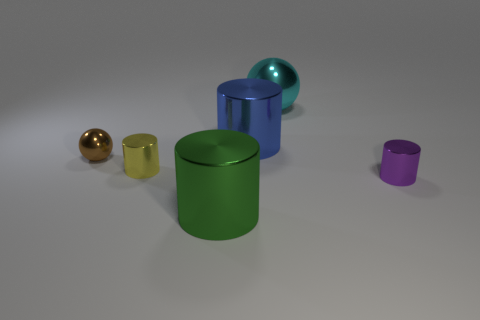Subtract 1 cylinders. How many cylinders are left? 3 Add 3 tiny yellow shiny cylinders. How many objects exist? 9 Subtract all cylinders. How many objects are left? 2 Subtract 0 red blocks. How many objects are left? 6 Subtract all big cubes. Subtract all big metal spheres. How many objects are left? 5 Add 6 shiny cylinders. How many shiny cylinders are left? 10 Add 3 large blue metal cylinders. How many large blue metal cylinders exist? 4 